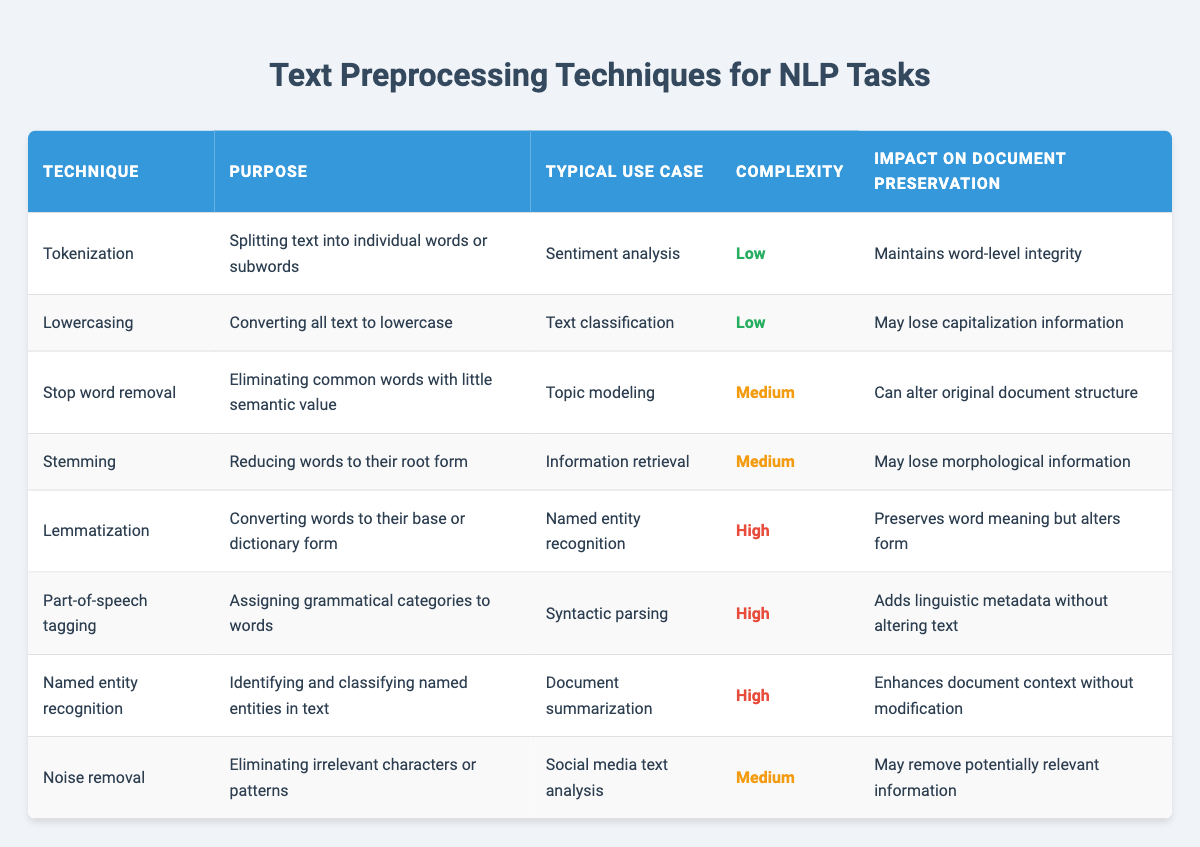What is the purpose of tokenization? Tokenization is the technique used to split text into individual words or subwords, making it easier for NLP tasks. This is directly mentioned in the "Purpose" column for the "Tokenization" row.
Answer: Splitting text into individual words or subwords Which preprocessing technique typically has a low complexity? By reviewing the "Complexity" column, both "Tokenization" and "Lowercasing" are marked with "Low" complexity. Therefore, both techniques are typically low in complexity.
Answer: Tokenization and Lowercasing Does stop word removal affect the structure of the document? The impact on document preservation for "Stop word removal" states that it can alter the original document structure. Therefore, the answer is yes.
Answer: Yes What is the highest complexity technique in the table? Checking the "Complexity" column, "Lemmatization", "Part-of-speech tagging", and "Named entity recognition" are all marked as "High". However, since they are all equally high, any of them can be considered the answer.
Answer: Lemmatization, Part-of-speech tagging, or Named entity recognition What is the impact of noise removal on document preservation? The impact on document preservation for "Noise removal" indicates that it may remove potentially relevant information, which suggests a negative impact on preservation. This can be concluded from the related row in the table.
Answer: May remove potentially relevant information What are the typical use cases for stemming and lemmatization? Referring to the "Typical Use Case" column, "Stemming" is used for information retrieval, while "Lemmatization" is used for named entity recognition. These values can be easily retrieved from their respective rows.
Answer: Information retrieval for stemming and named entity recognition for lemmatization How many techniques have a medium complexity level? Counting the entries labeled "Medium" in the "Complexity" column, we see that there are three techniques: "Stop word removal," "Stemming," and "Noise removal." Thus, the total count is three.
Answer: Three If a technique maintains word-level integrity, what is it? By examining the "Impact on Document Preservation" column, "Tokenization" is the technique that maintains word-level integrity according to its description.
Answer: Tokenization Which preprocessing techniques help preserve word meaning? Looking at the rows, "Lemmatization" is mentioned as preserving word meaning, while "Part-of-speech tagging" adds metadata without altering text. Therefore, both could be regarded as preserving meaning to some extent, but only lemmatization preserves Word meaning specifically.
Answer: Lemmatization 